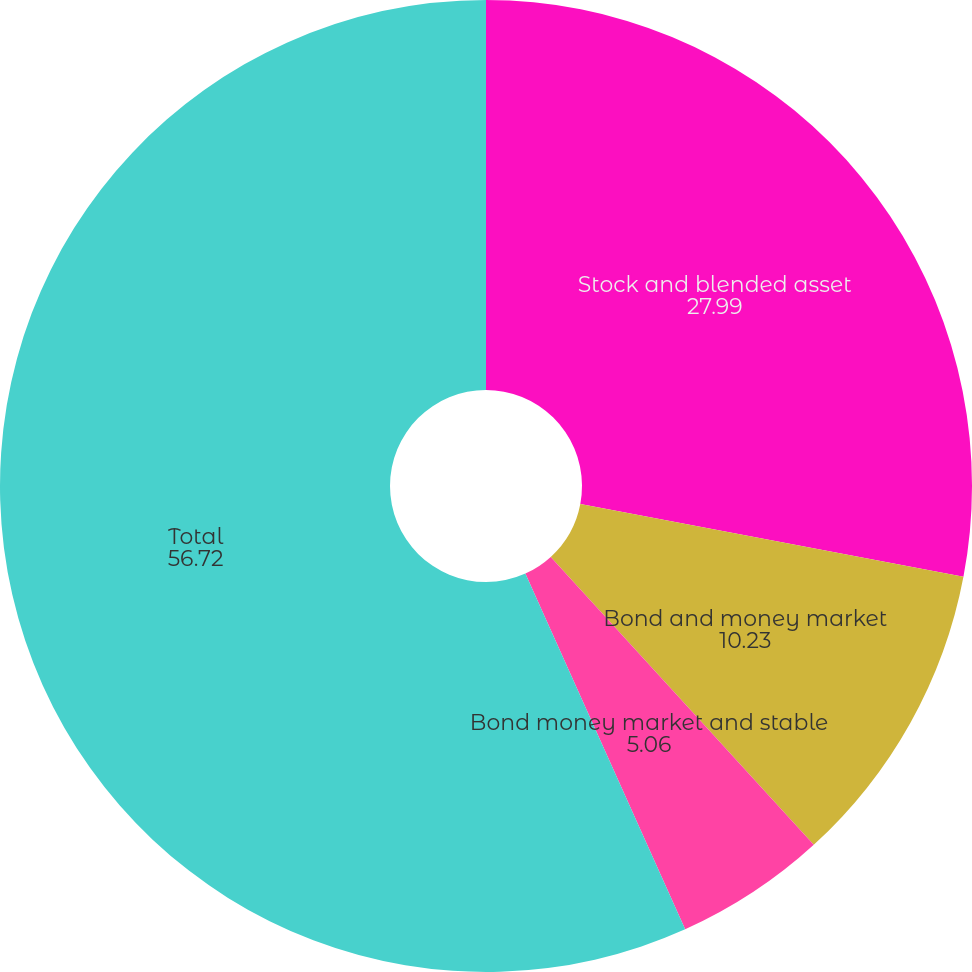Convert chart. <chart><loc_0><loc_0><loc_500><loc_500><pie_chart><fcel>Stock and blended asset<fcel>Bond and money market<fcel>Bond money market and stable<fcel>Total<nl><fcel>27.99%<fcel>10.23%<fcel>5.06%<fcel>56.72%<nl></chart> 